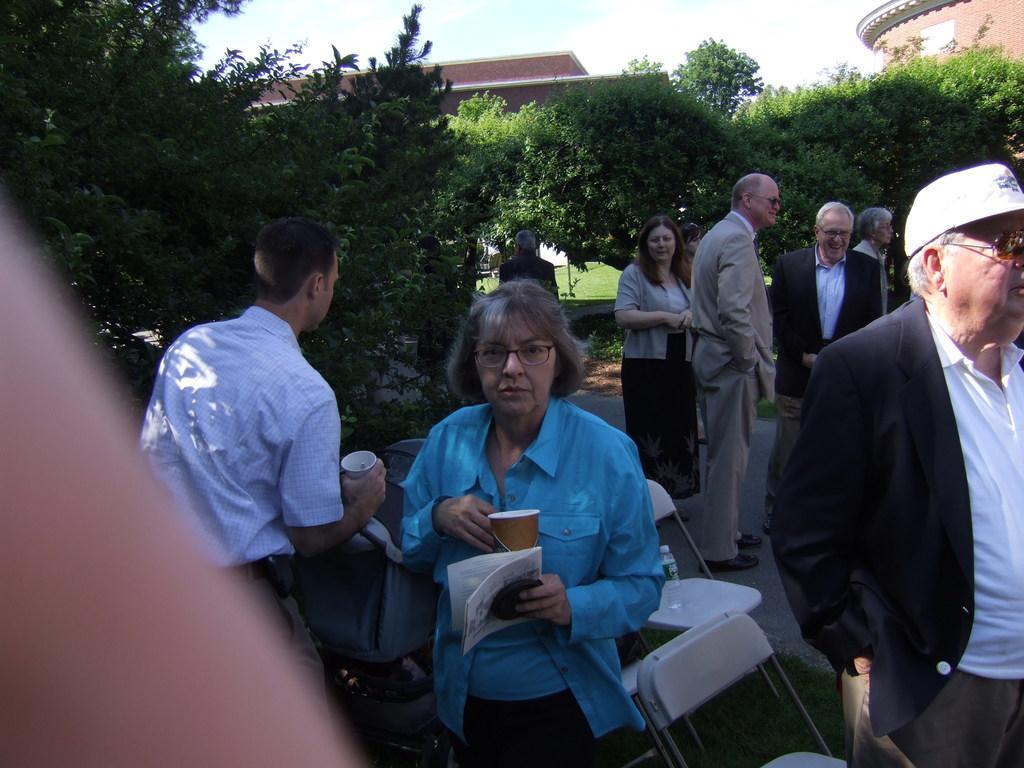How would you summarize this image in a sentence or two? In this image, we can see a group of people are standing. Few are holding some objects. Here we can see chairs, bottle, grass, walkway. Background we can see trees, houses, walls and sky. 